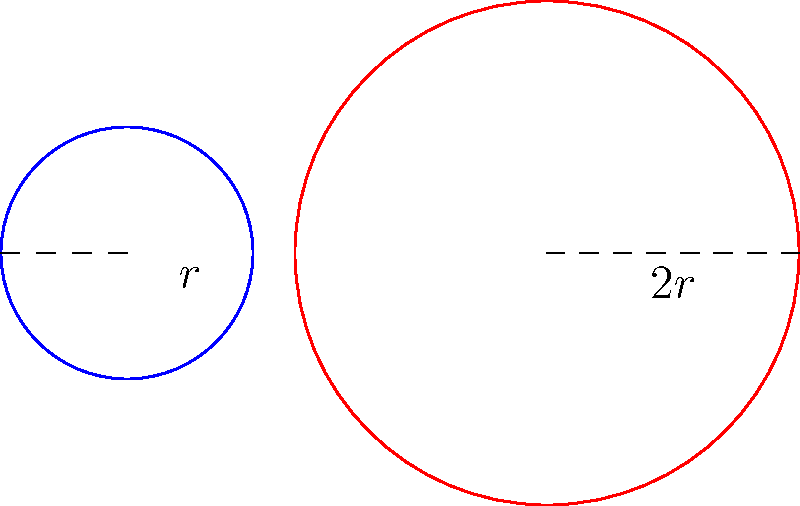In the context of reporting on women's rights in Yemen, consider two circles representing the spheres of influence for women in rural and urban areas. If the radius of the circle representing urban influence is twice that of the rural influence, what is the ratio of the area of the larger circle to the smaller one? Express your answer as a simplified fraction. Let's approach this step-by-step:

1) Let the radius of the smaller circle (representing rural influence) be $r$.

2) The radius of the larger circle (representing urban influence) is then $2r$.

3) The area of a circle is given by the formula $A = \pi r^2$.

4) For the smaller circle:
   Area $A_1 = \pi r^2$

5) For the larger circle:
   Area $A_2 = \pi (2r)^2 = \pi (4r^2) = 4\pi r^2$

6) The ratio of the areas is:
   $\frac{A_2}{A_1} = \frac{4\pi r^2}{\pi r^2}$

7) The $\pi$ and $r^2$ cancel out:
   $\frac{A_2}{A_1} = \frac{4}{1} = 4$

Therefore, the area of the larger circle is 4 times the area of the smaller circle.
Answer: $4:1$ or $4$ 